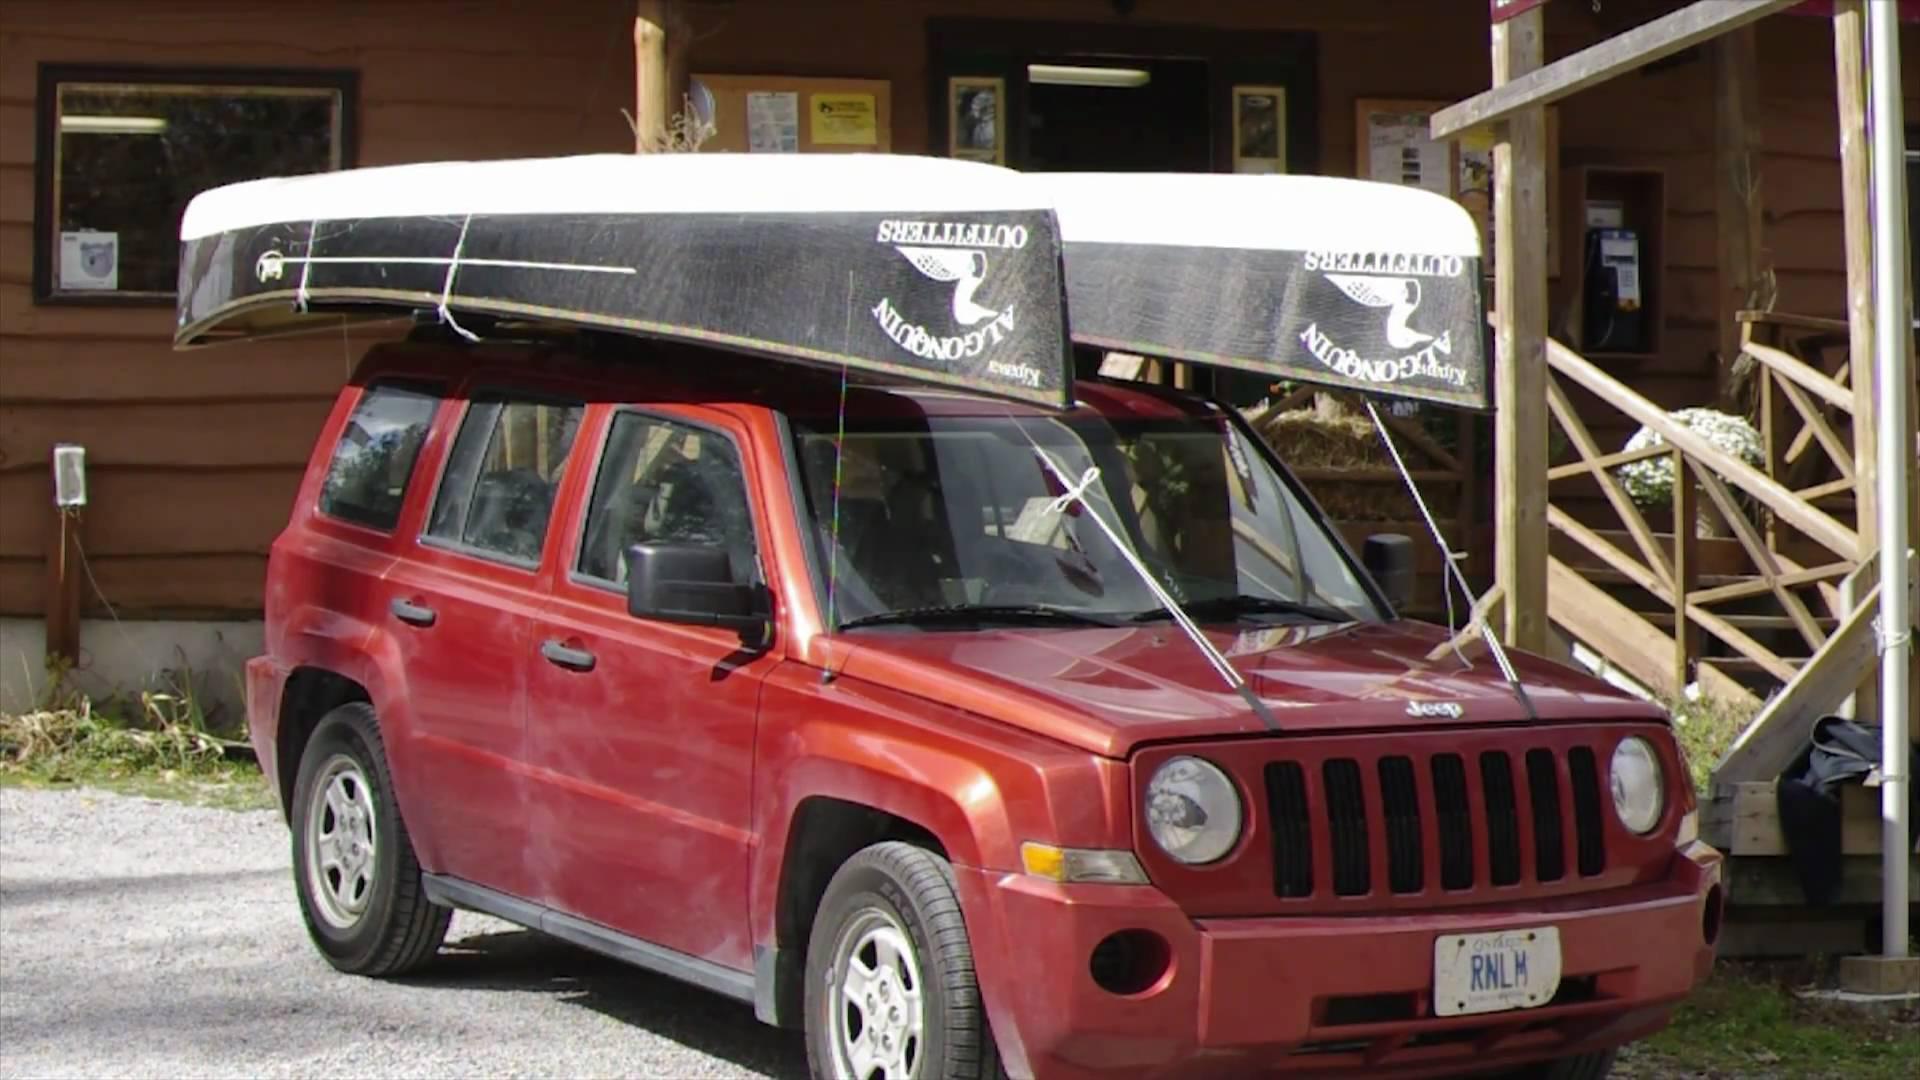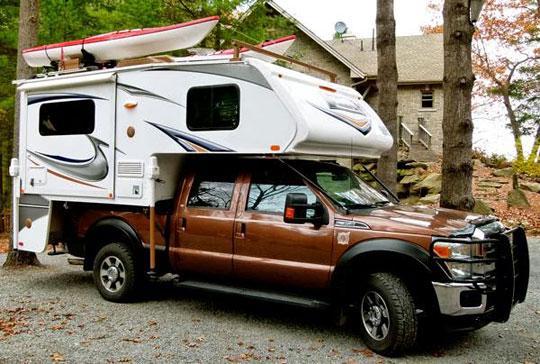The first image is the image on the left, the second image is the image on the right. Given the left and right images, does the statement "All vehicles have a single boat secured to the roof." hold true? Answer yes or no. No. 